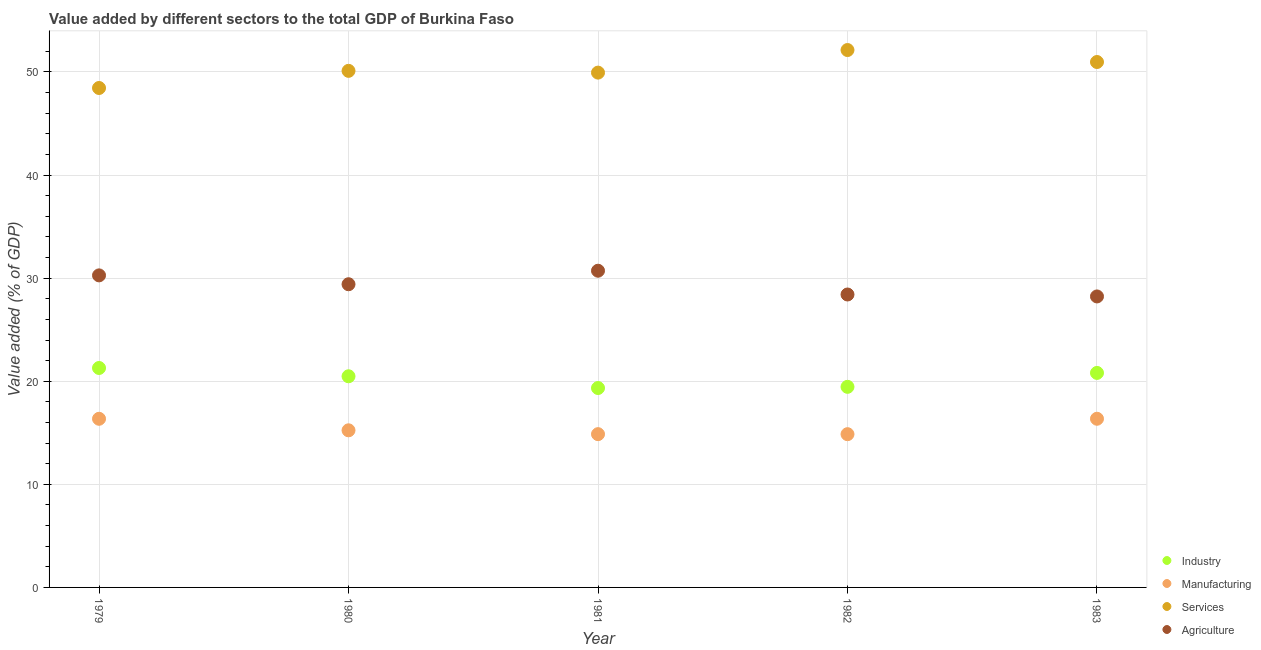How many different coloured dotlines are there?
Your answer should be compact. 4. What is the value added by industrial sector in 1980?
Offer a terse response. 20.48. Across all years, what is the maximum value added by manufacturing sector?
Make the answer very short. 16.36. Across all years, what is the minimum value added by agricultural sector?
Provide a succinct answer. 28.23. In which year was the value added by services sector maximum?
Offer a very short reply. 1982. In which year was the value added by services sector minimum?
Make the answer very short. 1979. What is the total value added by industrial sector in the graph?
Your response must be concise. 101.38. What is the difference between the value added by manufacturing sector in 1981 and that in 1983?
Offer a terse response. -1.49. What is the difference between the value added by agricultural sector in 1982 and the value added by industrial sector in 1979?
Your answer should be very brief. 7.13. What is the average value added by industrial sector per year?
Keep it short and to the point. 20.28. In the year 1981, what is the difference between the value added by services sector and value added by agricultural sector?
Offer a very short reply. 19.22. In how many years, is the value added by industrial sector greater than 20 %?
Your response must be concise. 3. What is the ratio of the value added by services sector in 1982 to that in 1983?
Your response must be concise. 1.02. Is the value added by services sector in 1980 less than that in 1981?
Your answer should be very brief. No. Is the difference between the value added by services sector in 1980 and 1982 greater than the difference between the value added by agricultural sector in 1980 and 1982?
Give a very brief answer. No. What is the difference between the highest and the second highest value added by agricultural sector?
Your answer should be compact. 0.45. What is the difference between the highest and the lowest value added by agricultural sector?
Your answer should be compact. 2.49. In how many years, is the value added by industrial sector greater than the average value added by industrial sector taken over all years?
Give a very brief answer. 3. Is it the case that in every year, the sum of the value added by industrial sector and value added by services sector is greater than the sum of value added by manufacturing sector and value added by agricultural sector?
Offer a terse response. Yes. Is it the case that in every year, the sum of the value added by industrial sector and value added by manufacturing sector is greater than the value added by services sector?
Offer a terse response. No. Does the value added by manufacturing sector monotonically increase over the years?
Keep it short and to the point. No. Is the value added by manufacturing sector strictly greater than the value added by agricultural sector over the years?
Keep it short and to the point. No. How many dotlines are there?
Provide a succinct answer. 4. Does the graph contain grids?
Provide a succinct answer. Yes. How many legend labels are there?
Your response must be concise. 4. What is the title of the graph?
Make the answer very short. Value added by different sectors to the total GDP of Burkina Faso. What is the label or title of the Y-axis?
Provide a succinct answer. Value added (% of GDP). What is the Value added (% of GDP) of Industry in 1979?
Your answer should be compact. 21.29. What is the Value added (% of GDP) in Manufacturing in 1979?
Offer a terse response. 16.36. What is the Value added (% of GDP) of Services in 1979?
Give a very brief answer. 48.45. What is the Value added (% of GDP) of Agriculture in 1979?
Provide a succinct answer. 30.27. What is the Value added (% of GDP) of Industry in 1980?
Your answer should be compact. 20.48. What is the Value added (% of GDP) in Manufacturing in 1980?
Your response must be concise. 15.24. What is the Value added (% of GDP) of Services in 1980?
Your answer should be very brief. 50.11. What is the Value added (% of GDP) in Agriculture in 1980?
Your response must be concise. 29.41. What is the Value added (% of GDP) of Industry in 1981?
Your response must be concise. 19.34. What is the Value added (% of GDP) in Manufacturing in 1981?
Give a very brief answer. 14.87. What is the Value added (% of GDP) in Services in 1981?
Ensure brevity in your answer.  49.94. What is the Value added (% of GDP) of Agriculture in 1981?
Your answer should be compact. 30.72. What is the Value added (% of GDP) in Industry in 1982?
Keep it short and to the point. 19.46. What is the Value added (% of GDP) of Manufacturing in 1982?
Your answer should be very brief. 14.87. What is the Value added (% of GDP) in Services in 1982?
Your answer should be compact. 52.13. What is the Value added (% of GDP) of Agriculture in 1982?
Your answer should be very brief. 28.41. What is the Value added (% of GDP) in Industry in 1983?
Provide a succinct answer. 20.81. What is the Value added (% of GDP) of Manufacturing in 1983?
Your response must be concise. 16.36. What is the Value added (% of GDP) in Services in 1983?
Provide a succinct answer. 50.97. What is the Value added (% of GDP) in Agriculture in 1983?
Ensure brevity in your answer.  28.23. Across all years, what is the maximum Value added (% of GDP) in Industry?
Provide a succinct answer. 21.29. Across all years, what is the maximum Value added (% of GDP) in Manufacturing?
Offer a very short reply. 16.36. Across all years, what is the maximum Value added (% of GDP) of Services?
Your answer should be very brief. 52.13. Across all years, what is the maximum Value added (% of GDP) in Agriculture?
Make the answer very short. 30.72. Across all years, what is the minimum Value added (% of GDP) of Industry?
Make the answer very short. 19.34. Across all years, what is the minimum Value added (% of GDP) in Manufacturing?
Your response must be concise. 14.87. Across all years, what is the minimum Value added (% of GDP) of Services?
Make the answer very short. 48.45. Across all years, what is the minimum Value added (% of GDP) of Agriculture?
Ensure brevity in your answer.  28.23. What is the total Value added (% of GDP) of Industry in the graph?
Your answer should be compact. 101.38. What is the total Value added (% of GDP) in Manufacturing in the graph?
Your answer should be compact. 77.69. What is the total Value added (% of GDP) of Services in the graph?
Ensure brevity in your answer.  251.58. What is the total Value added (% of GDP) in Agriculture in the graph?
Offer a very short reply. 147.04. What is the difference between the Value added (% of GDP) of Industry in 1979 and that in 1980?
Make the answer very short. 0.8. What is the difference between the Value added (% of GDP) of Manufacturing in 1979 and that in 1980?
Your answer should be compact. 1.12. What is the difference between the Value added (% of GDP) of Services in 1979 and that in 1980?
Keep it short and to the point. -1.66. What is the difference between the Value added (% of GDP) of Agriculture in 1979 and that in 1980?
Give a very brief answer. 0.86. What is the difference between the Value added (% of GDP) of Industry in 1979 and that in 1981?
Offer a terse response. 1.94. What is the difference between the Value added (% of GDP) of Manufacturing in 1979 and that in 1981?
Give a very brief answer. 1.49. What is the difference between the Value added (% of GDP) of Services in 1979 and that in 1981?
Provide a short and direct response. -1.49. What is the difference between the Value added (% of GDP) of Agriculture in 1979 and that in 1981?
Offer a very short reply. -0.45. What is the difference between the Value added (% of GDP) of Industry in 1979 and that in 1982?
Offer a terse response. 1.83. What is the difference between the Value added (% of GDP) in Manufacturing in 1979 and that in 1982?
Ensure brevity in your answer.  1.49. What is the difference between the Value added (% of GDP) of Services in 1979 and that in 1982?
Your answer should be compact. -3.68. What is the difference between the Value added (% of GDP) of Agriculture in 1979 and that in 1982?
Make the answer very short. 1.85. What is the difference between the Value added (% of GDP) in Industry in 1979 and that in 1983?
Keep it short and to the point. 0.48. What is the difference between the Value added (% of GDP) of Manufacturing in 1979 and that in 1983?
Offer a terse response. -0. What is the difference between the Value added (% of GDP) of Services in 1979 and that in 1983?
Provide a succinct answer. -2.52. What is the difference between the Value added (% of GDP) in Agriculture in 1979 and that in 1983?
Offer a terse response. 2.04. What is the difference between the Value added (% of GDP) in Industry in 1980 and that in 1981?
Keep it short and to the point. 1.14. What is the difference between the Value added (% of GDP) in Manufacturing in 1980 and that in 1981?
Keep it short and to the point. 0.37. What is the difference between the Value added (% of GDP) in Services in 1980 and that in 1981?
Your answer should be very brief. 0.17. What is the difference between the Value added (% of GDP) of Agriculture in 1980 and that in 1981?
Provide a succinct answer. -1.31. What is the difference between the Value added (% of GDP) of Industry in 1980 and that in 1982?
Offer a terse response. 1.02. What is the difference between the Value added (% of GDP) in Manufacturing in 1980 and that in 1982?
Offer a very short reply. 0.38. What is the difference between the Value added (% of GDP) of Services in 1980 and that in 1982?
Keep it short and to the point. -2.02. What is the difference between the Value added (% of GDP) in Agriculture in 1980 and that in 1982?
Offer a very short reply. 1. What is the difference between the Value added (% of GDP) of Industry in 1980 and that in 1983?
Your answer should be very brief. -0.33. What is the difference between the Value added (% of GDP) in Manufacturing in 1980 and that in 1983?
Ensure brevity in your answer.  -1.12. What is the difference between the Value added (% of GDP) of Services in 1980 and that in 1983?
Your answer should be compact. -0.86. What is the difference between the Value added (% of GDP) of Agriculture in 1980 and that in 1983?
Provide a short and direct response. 1.18. What is the difference between the Value added (% of GDP) in Industry in 1981 and that in 1982?
Give a very brief answer. -0.11. What is the difference between the Value added (% of GDP) in Manufacturing in 1981 and that in 1982?
Offer a terse response. 0. What is the difference between the Value added (% of GDP) in Services in 1981 and that in 1982?
Make the answer very short. -2.19. What is the difference between the Value added (% of GDP) of Agriculture in 1981 and that in 1982?
Keep it short and to the point. 2.31. What is the difference between the Value added (% of GDP) of Industry in 1981 and that in 1983?
Provide a short and direct response. -1.47. What is the difference between the Value added (% of GDP) of Manufacturing in 1981 and that in 1983?
Provide a short and direct response. -1.49. What is the difference between the Value added (% of GDP) in Services in 1981 and that in 1983?
Offer a very short reply. -1.03. What is the difference between the Value added (% of GDP) of Agriculture in 1981 and that in 1983?
Your answer should be compact. 2.49. What is the difference between the Value added (% of GDP) of Industry in 1982 and that in 1983?
Give a very brief answer. -1.35. What is the difference between the Value added (% of GDP) in Manufacturing in 1982 and that in 1983?
Your answer should be compact. -1.5. What is the difference between the Value added (% of GDP) of Services in 1982 and that in 1983?
Make the answer very short. 1.16. What is the difference between the Value added (% of GDP) in Agriculture in 1982 and that in 1983?
Your answer should be very brief. 0.19. What is the difference between the Value added (% of GDP) in Industry in 1979 and the Value added (% of GDP) in Manufacturing in 1980?
Ensure brevity in your answer.  6.04. What is the difference between the Value added (% of GDP) of Industry in 1979 and the Value added (% of GDP) of Services in 1980?
Keep it short and to the point. -28.82. What is the difference between the Value added (% of GDP) of Industry in 1979 and the Value added (% of GDP) of Agriculture in 1980?
Your answer should be very brief. -8.12. What is the difference between the Value added (% of GDP) in Manufacturing in 1979 and the Value added (% of GDP) in Services in 1980?
Offer a terse response. -33.75. What is the difference between the Value added (% of GDP) of Manufacturing in 1979 and the Value added (% of GDP) of Agriculture in 1980?
Ensure brevity in your answer.  -13.05. What is the difference between the Value added (% of GDP) in Services in 1979 and the Value added (% of GDP) in Agriculture in 1980?
Provide a succinct answer. 19.04. What is the difference between the Value added (% of GDP) in Industry in 1979 and the Value added (% of GDP) in Manufacturing in 1981?
Offer a very short reply. 6.42. What is the difference between the Value added (% of GDP) in Industry in 1979 and the Value added (% of GDP) in Services in 1981?
Your response must be concise. -28.65. What is the difference between the Value added (% of GDP) of Industry in 1979 and the Value added (% of GDP) of Agriculture in 1981?
Make the answer very short. -9.43. What is the difference between the Value added (% of GDP) of Manufacturing in 1979 and the Value added (% of GDP) of Services in 1981?
Your answer should be compact. -33.58. What is the difference between the Value added (% of GDP) in Manufacturing in 1979 and the Value added (% of GDP) in Agriculture in 1981?
Make the answer very short. -14.36. What is the difference between the Value added (% of GDP) in Services in 1979 and the Value added (% of GDP) in Agriculture in 1981?
Keep it short and to the point. 17.73. What is the difference between the Value added (% of GDP) in Industry in 1979 and the Value added (% of GDP) in Manufacturing in 1982?
Keep it short and to the point. 6.42. What is the difference between the Value added (% of GDP) in Industry in 1979 and the Value added (% of GDP) in Services in 1982?
Offer a very short reply. -30.84. What is the difference between the Value added (% of GDP) of Industry in 1979 and the Value added (% of GDP) of Agriculture in 1982?
Give a very brief answer. -7.13. What is the difference between the Value added (% of GDP) of Manufacturing in 1979 and the Value added (% of GDP) of Services in 1982?
Ensure brevity in your answer.  -35.77. What is the difference between the Value added (% of GDP) of Manufacturing in 1979 and the Value added (% of GDP) of Agriculture in 1982?
Offer a very short reply. -12.06. What is the difference between the Value added (% of GDP) of Services in 1979 and the Value added (% of GDP) of Agriculture in 1982?
Your response must be concise. 20.03. What is the difference between the Value added (% of GDP) of Industry in 1979 and the Value added (% of GDP) of Manufacturing in 1983?
Offer a terse response. 4.92. What is the difference between the Value added (% of GDP) of Industry in 1979 and the Value added (% of GDP) of Services in 1983?
Your response must be concise. -29.68. What is the difference between the Value added (% of GDP) of Industry in 1979 and the Value added (% of GDP) of Agriculture in 1983?
Provide a short and direct response. -6.94. What is the difference between the Value added (% of GDP) in Manufacturing in 1979 and the Value added (% of GDP) in Services in 1983?
Ensure brevity in your answer.  -34.61. What is the difference between the Value added (% of GDP) in Manufacturing in 1979 and the Value added (% of GDP) in Agriculture in 1983?
Your answer should be very brief. -11.87. What is the difference between the Value added (% of GDP) of Services in 1979 and the Value added (% of GDP) of Agriculture in 1983?
Keep it short and to the point. 20.22. What is the difference between the Value added (% of GDP) of Industry in 1980 and the Value added (% of GDP) of Manufacturing in 1981?
Offer a very short reply. 5.61. What is the difference between the Value added (% of GDP) in Industry in 1980 and the Value added (% of GDP) in Services in 1981?
Provide a succinct answer. -29.46. What is the difference between the Value added (% of GDP) of Industry in 1980 and the Value added (% of GDP) of Agriculture in 1981?
Your answer should be compact. -10.24. What is the difference between the Value added (% of GDP) in Manufacturing in 1980 and the Value added (% of GDP) in Services in 1981?
Ensure brevity in your answer.  -34.7. What is the difference between the Value added (% of GDP) of Manufacturing in 1980 and the Value added (% of GDP) of Agriculture in 1981?
Offer a terse response. -15.48. What is the difference between the Value added (% of GDP) of Services in 1980 and the Value added (% of GDP) of Agriculture in 1981?
Your answer should be compact. 19.39. What is the difference between the Value added (% of GDP) of Industry in 1980 and the Value added (% of GDP) of Manufacturing in 1982?
Ensure brevity in your answer.  5.62. What is the difference between the Value added (% of GDP) of Industry in 1980 and the Value added (% of GDP) of Services in 1982?
Offer a very short reply. -31.65. What is the difference between the Value added (% of GDP) in Industry in 1980 and the Value added (% of GDP) in Agriculture in 1982?
Keep it short and to the point. -7.93. What is the difference between the Value added (% of GDP) of Manufacturing in 1980 and the Value added (% of GDP) of Services in 1982?
Your response must be concise. -36.89. What is the difference between the Value added (% of GDP) of Manufacturing in 1980 and the Value added (% of GDP) of Agriculture in 1982?
Provide a succinct answer. -13.17. What is the difference between the Value added (% of GDP) in Services in 1980 and the Value added (% of GDP) in Agriculture in 1982?
Offer a terse response. 21.69. What is the difference between the Value added (% of GDP) of Industry in 1980 and the Value added (% of GDP) of Manufacturing in 1983?
Provide a short and direct response. 4.12. What is the difference between the Value added (% of GDP) in Industry in 1980 and the Value added (% of GDP) in Services in 1983?
Give a very brief answer. -30.48. What is the difference between the Value added (% of GDP) in Industry in 1980 and the Value added (% of GDP) in Agriculture in 1983?
Make the answer very short. -7.74. What is the difference between the Value added (% of GDP) of Manufacturing in 1980 and the Value added (% of GDP) of Services in 1983?
Your answer should be very brief. -35.73. What is the difference between the Value added (% of GDP) of Manufacturing in 1980 and the Value added (% of GDP) of Agriculture in 1983?
Offer a terse response. -12.99. What is the difference between the Value added (% of GDP) in Services in 1980 and the Value added (% of GDP) in Agriculture in 1983?
Offer a terse response. 21.88. What is the difference between the Value added (% of GDP) in Industry in 1981 and the Value added (% of GDP) in Manufacturing in 1982?
Give a very brief answer. 4.48. What is the difference between the Value added (% of GDP) of Industry in 1981 and the Value added (% of GDP) of Services in 1982?
Make the answer very short. -32.79. What is the difference between the Value added (% of GDP) of Industry in 1981 and the Value added (% of GDP) of Agriculture in 1982?
Give a very brief answer. -9.07. What is the difference between the Value added (% of GDP) of Manufacturing in 1981 and the Value added (% of GDP) of Services in 1982?
Your answer should be very brief. -37.26. What is the difference between the Value added (% of GDP) in Manufacturing in 1981 and the Value added (% of GDP) in Agriculture in 1982?
Your response must be concise. -13.55. What is the difference between the Value added (% of GDP) of Services in 1981 and the Value added (% of GDP) of Agriculture in 1982?
Ensure brevity in your answer.  21.52. What is the difference between the Value added (% of GDP) in Industry in 1981 and the Value added (% of GDP) in Manufacturing in 1983?
Offer a very short reply. 2.98. What is the difference between the Value added (% of GDP) of Industry in 1981 and the Value added (% of GDP) of Services in 1983?
Offer a very short reply. -31.62. What is the difference between the Value added (% of GDP) in Industry in 1981 and the Value added (% of GDP) in Agriculture in 1983?
Give a very brief answer. -8.88. What is the difference between the Value added (% of GDP) in Manufacturing in 1981 and the Value added (% of GDP) in Services in 1983?
Ensure brevity in your answer.  -36.1. What is the difference between the Value added (% of GDP) of Manufacturing in 1981 and the Value added (% of GDP) of Agriculture in 1983?
Keep it short and to the point. -13.36. What is the difference between the Value added (% of GDP) of Services in 1981 and the Value added (% of GDP) of Agriculture in 1983?
Ensure brevity in your answer.  21.71. What is the difference between the Value added (% of GDP) in Industry in 1982 and the Value added (% of GDP) in Manufacturing in 1983?
Keep it short and to the point. 3.1. What is the difference between the Value added (% of GDP) in Industry in 1982 and the Value added (% of GDP) in Services in 1983?
Your answer should be very brief. -31.51. What is the difference between the Value added (% of GDP) of Industry in 1982 and the Value added (% of GDP) of Agriculture in 1983?
Your response must be concise. -8.77. What is the difference between the Value added (% of GDP) of Manufacturing in 1982 and the Value added (% of GDP) of Services in 1983?
Give a very brief answer. -36.1. What is the difference between the Value added (% of GDP) of Manufacturing in 1982 and the Value added (% of GDP) of Agriculture in 1983?
Provide a short and direct response. -13.36. What is the difference between the Value added (% of GDP) in Services in 1982 and the Value added (% of GDP) in Agriculture in 1983?
Provide a short and direct response. 23.9. What is the average Value added (% of GDP) in Industry per year?
Make the answer very short. 20.28. What is the average Value added (% of GDP) in Manufacturing per year?
Provide a short and direct response. 15.54. What is the average Value added (% of GDP) in Services per year?
Your answer should be compact. 50.32. What is the average Value added (% of GDP) in Agriculture per year?
Offer a terse response. 29.41. In the year 1979, what is the difference between the Value added (% of GDP) of Industry and Value added (% of GDP) of Manufacturing?
Offer a very short reply. 4.93. In the year 1979, what is the difference between the Value added (% of GDP) in Industry and Value added (% of GDP) in Services?
Your response must be concise. -27.16. In the year 1979, what is the difference between the Value added (% of GDP) in Industry and Value added (% of GDP) in Agriculture?
Your response must be concise. -8.98. In the year 1979, what is the difference between the Value added (% of GDP) in Manufacturing and Value added (% of GDP) in Services?
Make the answer very short. -32.09. In the year 1979, what is the difference between the Value added (% of GDP) in Manufacturing and Value added (% of GDP) in Agriculture?
Provide a succinct answer. -13.91. In the year 1979, what is the difference between the Value added (% of GDP) in Services and Value added (% of GDP) in Agriculture?
Your response must be concise. 18.18. In the year 1980, what is the difference between the Value added (% of GDP) in Industry and Value added (% of GDP) in Manufacturing?
Offer a very short reply. 5.24. In the year 1980, what is the difference between the Value added (% of GDP) in Industry and Value added (% of GDP) in Services?
Make the answer very short. -29.63. In the year 1980, what is the difference between the Value added (% of GDP) of Industry and Value added (% of GDP) of Agriculture?
Make the answer very short. -8.93. In the year 1980, what is the difference between the Value added (% of GDP) of Manufacturing and Value added (% of GDP) of Services?
Offer a terse response. -34.87. In the year 1980, what is the difference between the Value added (% of GDP) in Manufacturing and Value added (% of GDP) in Agriculture?
Offer a terse response. -14.17. In the year 1980, what is the difference between the Value added (% of GDP) in Services and Value added (% of GDP) in Agriculture?
Provide a succinct answer. 20.7. In the year 1981, what is the difference between the Value added (% of GDP) of Industry and Value added (% of GDP) of Manufacturing?
Your answer should be compact. 4.47. In the year 1981, what is the difference between the Value added (% of GDP) in Industry and Value added (% of GDP) in Services?
Your response must be concise. -30.59. In the year 1981, what is the difference between the Value added (% of GDP) in Industry and Value added (% of GDP) in Agriculture?
Your answer should be compact. -11.38. In the year 1981, what is the difference between the Value added (% of GDP) in Manufacturing and Value added (% of GDP) in Services?
Provide a succinct answer. -35.07. In the year 1981, what is the difference between the Value added (% of GDP) of Manufacturing and Value added (% of GDP) of Agriculture?
Make the answer very short. -15.85. In the year 1981, what is the difference between the Value added (% of GDP) in Services and Value added (% of GDP) in Agriculture?
Keep it short and to the point. 19.22. In the year 1982, what is the difference between the Value added (% of GDP) in Industry and Value added (% of GDP) in Manufacturing?
Offer a very short reply. 4.59. In the year 1982, what is the difference between the Value added (% of GDP) of Industry and Value added (% of GDP) of Services?
Keep it short and to the point. -32.67. In the year 1982, what is the difference between the Value added (% of GDP) of Industry and Value added (% of GDP) of Agriculture?
Provide a short and direct response. -8.96. In the year 1982, what is the difference between the Value added (% of GDP) of Manufacturing and Value added (% of GDP) of Services?
Offer a very short reply. -37.26. In the year 1982, what is the difference between the Value added (% of GDP) of Manufacturing and Value added (% of GDP) of Agriculture?
Keep it short and to the point. -13.55. In the year 1982, what is the difference between the Value added (% of GDP) in Services and Value added (% of GDP) in Agriculture?
Your response must be concise. 23.71. In the year 1983, what is the difference between the Value added (% of GDP) in Industry and Value added (% of GDP) in Manufacturing?
Your answer should be compact. 4.45. In the year 1983, what is the difference between the Value added (% of GDP) of Industry and Value added (% of GDP) of Services?
Provide a short and direct response. -30.16. In the year 1983, what is the difference between the Value added (% of GDP) of Industry and Value added (% of GDP) of Agriculture?
Make the answer very short. -7.42. In the year 1983, what is the difference between the Value added (% of GDP) in Manufacturing and Value added (% of GDP) in Services?
Provide a succinct answer. -34.61. In the year 1983, what is the difference between the Value added (% of GDP) in Manufacturing and Value added (% of GDP) in Agriculture?
Provide a succinct answer. -11.86. In the year 1983, what is the difference between the Value added (% of GDP) of Services and Value added (% of GDP) of Agriculture?
Ensure brevity in your answer.  22.74. What is the ratio of the Value added (% of GDP) of Industry in 1979 to that in 1980?
Provide a short and direct response. 1.04. What is the ratio of the Value added (% of GDP) in Manufacturing in 1979 to that in 1980?
Provide a short and direct response. 1.07. What is the ratio of the Value added (% of GDP) of Services in 1979 to that in 1980?
Provide a succinct answer. 0.97. What is the ratio of the Value added (% of GDP) in Agriculture in 1979 to that in 1980?
Offer a terse response. 1.03. What is the ratio of the Value added (% of GDP) of Industry in 1979 to that in 1981?
Your answer should be very brief. 1.1. What is the ratio of the Value added (% of GDP) of Manufacturing in 1979 to that in 1981?
Keep it short and to the point. 1.1. What is the ratio of the Value added (% of GDP) of Services in 1979 to that in 1981?
Offer a very short reply. 0.97. What is the ratio of the Value added (% of GDP) of Agriculture in 1979 to that in 1981?
Keep it short and to the point. 0.99. What is the ratio of the Value added (% of GDP) in Industry in 1979 to that in 1982?
Your response must be concise. 1.09. What is the ratio of the Value added (% of GDP) in Manufacturing in 1979 to that in 1982?
Keep it short and to the point. 1.1. What is the ratio of the Value added (% of GDP) in Services in 1979 to that in 1982?
Make the answer very short. 0.93. What is the ratio of the Value added (% of GDP) of Agriculture in 1979 to that in 1982?
Give a very brief answer. 1.07. What is the ratio of the Value added (% of GDP) in Industry in 1979 to that in 1983?
Keep it short and to the point. 1.02. What is the ratio of the Value added (% of GDP) in Manufacturing in 1979 to that in 1983?
Your response must be concise. 1. What is the ratio of the Value added (% of GDP) of Services in 1979 to that in 1983?
Your response must be concise. 0.95. What is the ratio of the Value added (% of GDP) in Agriculture in 1979 to that in 1983?
Offer a very short reply. 1.07. What is the ratio of the Value added (% of GDP) in Industry in 1980 to that in 1981?
Offer a terse response. 1.06. What is the ratio of the Value added (% of GDP) of Manufacturing in 1980 to that in 1981?
Keep it short and to the point. 1.02. What is the ratio of the Value added (% of GDP) in Services in 1980 to that in 1981?
Ensure brevity in your answer.  1. What is the ratio of the Value added (% of GDP) of Agriculture in 1980 to that in 1981?
Make the answer very short. 0.96. What is the ratio of the Value added (% of GDP) in Industry in 1980 to that in 1982?
Your response must be concise. 1.05. What is the ratio of the Value added (% of GDP) of Manufacturing in 1980 to that in 1982?
Make the answer very short. 1.03. What is the ratio of the Value added (% of GDP) of Services in 1980 to that in 1982?
Provide a short and direct response. 0.96. What is the ratio of the Value added (% of GDP) of Agriculture in 1980 to that in 1982?
Ensure brevity in your answer.  1.03. What is the ratio of the Value added (% of GDP) of Industry in 1980 to that in 1983?
Your answer should be very brief. 0.98. What is the ratio of the Value added (% of GDP) in Manufacturing in 1980 to that in 1983?
Ensure brevity in your answer.  0.93. What is the ratio of the Value added (% of GDP) in Services in 1980 to that in 1983?
Offer a terse response. 0.98. What is the ratio of the Value added (% of GDP) of Agriculture in 1980 to that in 1983?
Make the answer very short. 1.04. What is the ratio of the Value added (% of GDP) of Industry in 1981 to that in 1982?
Your answer should be compact. 0.99. What is the ratio of the Value added (% of GDP) of Manufacturing in 1981 to that in 1982?
Offer a very short reply. 1. What is the ratio of the Value added (% of GDP) in Services in 1981 to that in 1982?
Provide a short and direct response. 0.96. What is the ratio of the Value added (% of GDP) in Agriculture in 1981 to that in 1982?
Keep it short and to the point. 1.08. What is the ratio of the Value added (% of GDP) in Industry in 1981 to that in 1983?
Ensure brevity in your answer.  0.93. What is the ratio of the Value added (% of GDP) of Manufacturing in 1981 to that in 1983?
Make the answer very short. 0.91. What is the ratio of the Value added (% of GDP) of Services in 1981 to that in 1983?
Your answer should be very brief. 0.98. What is the ratio of the Value added (% of GDP) of Agriculture in 1981 to that in 1983?
Provide a succinct answer. 1.09. What is the ratio of the Value added (% of GDP) in Industry in 1982 to that in 1983?
Your answer should be very brief. 0.94. What is the ratio of the Value added (% of GDP) of Manufacturing in 1982 to that in 1983?
Provide a succinct answer. 0.91. What is the ratio of the Value added (% of GDP) of Services in 1982 to that in 1983?
Your answer should be very brief. 1.02. What is the difference between the highest and the second highest Value added (% of GDP) of Industry?
Make the answer very short. 0.48. What is the difference between the highest and the second highest Value added (% of GDP) in Manufacturing?
Offer a very short reply. 0. What is the difference between the highest and the second highest Value added (% of GDP) of Services?
Offer a very short reply. 1.16. What is the difference between the highest and the second highest Value added (% of GDP) in Agriculture?
Your answer should be very brief. 0.45. What is the difference between the highest and the lowest Value added (% of GDP) of Industry?
Provide a succinct answer. 1.94. What is the difference between the highest and the lowest Value added (% of GDP) in Manufacturing?
Your response must be concise. 1.5. What is the difference between the highest and the lowest Value added (% of GDP) in Services?
Your answer should be compact. 3.68. What is the difference between the highest and the lowest Value added (% of GDP) in Agriculture?
Make the answer very short. 2.49. 